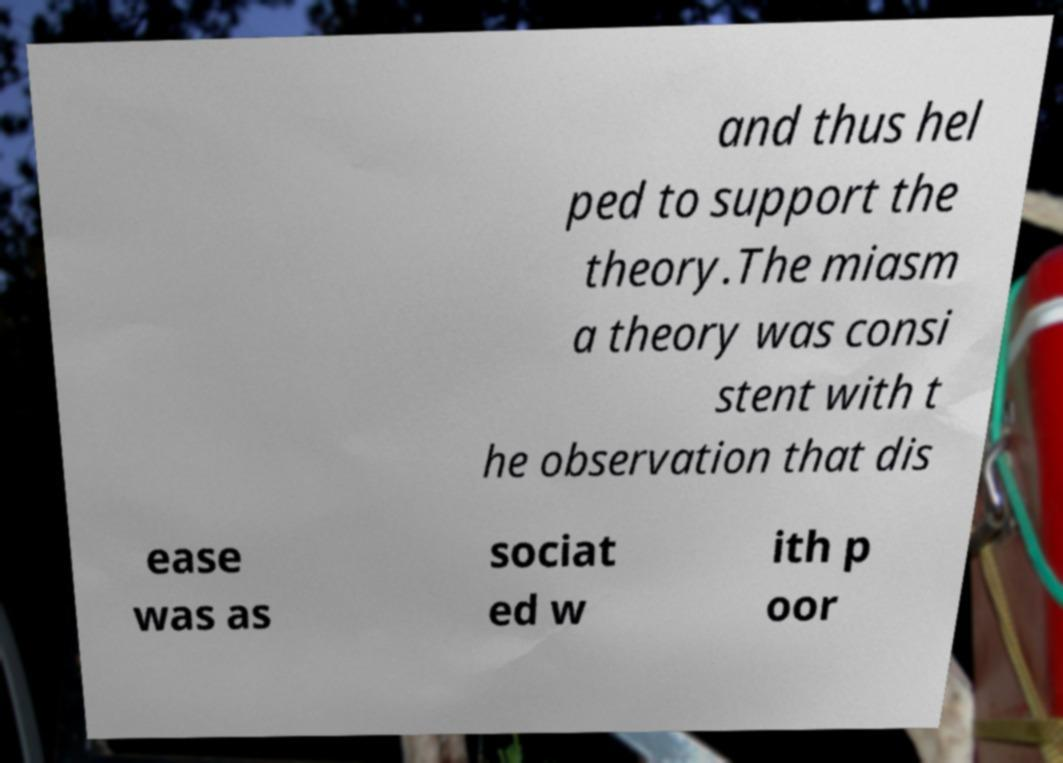Could you extract and type out the text from this image? and thus hel ped to support the theory.The miasm a theory was consi stent with t he observation that dis ease was as sociat ed w ith p oor 